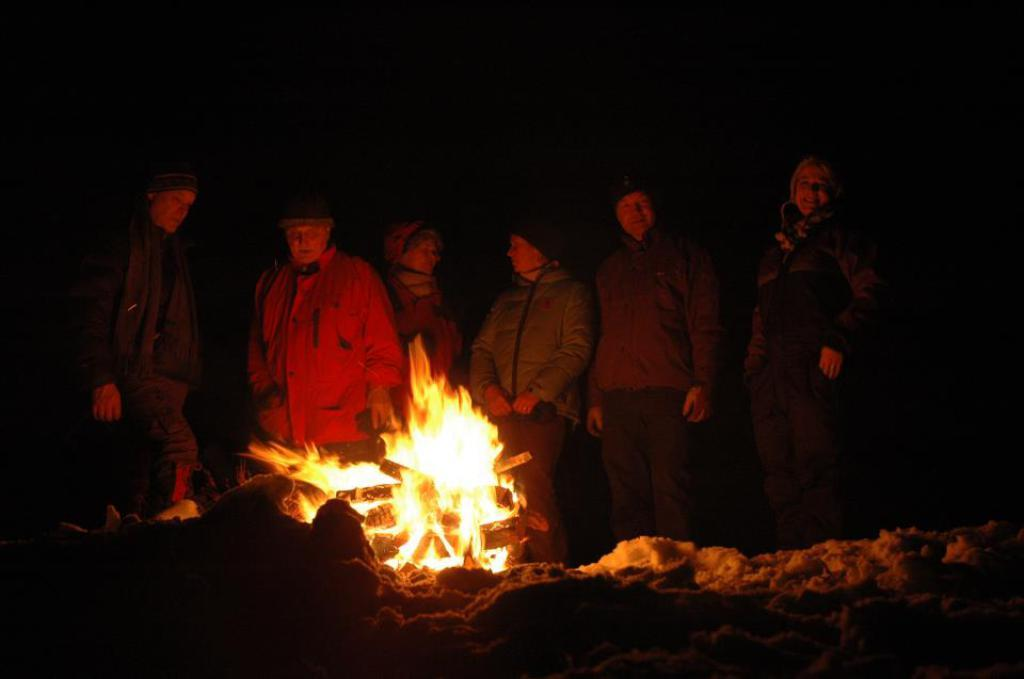How many people are in the image? There are people in the image, but the exact number is not specified. What are the people in the image doing? The people are standing in front of a campfire. What news channel are the people watching in the image? There is no indication in the image that the people are watching a news channel. What is the main attraction in the image? The main attraction in the image is the campfire, as the people are standing in front of it. 